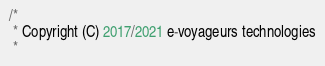<code> <loc_0><loc_0><loc_500><loc_500><_Kotlin_>/*
 * Copyright (C) 2017/2021 e-voyageurs technologies
 *</code> 